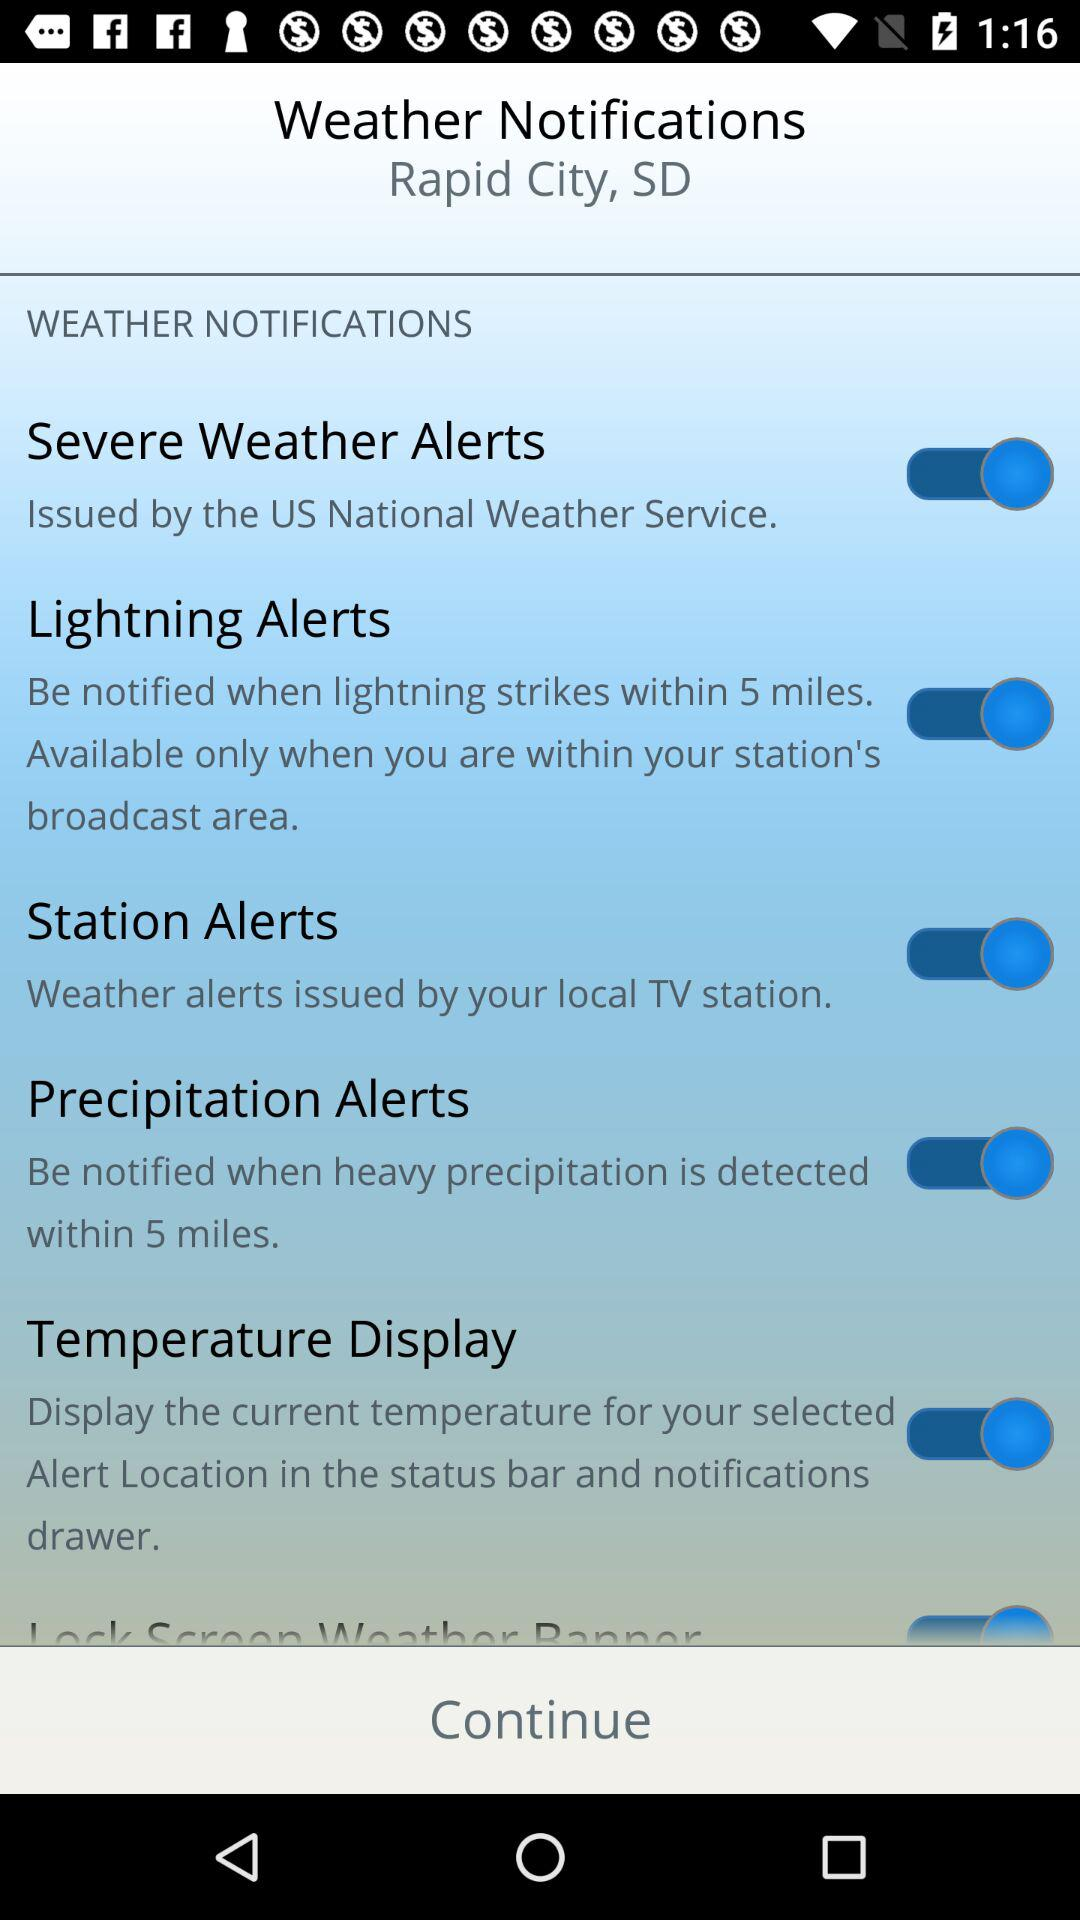Within what range will the lightning alerts be given? The lightning alerts will be given within 5 miles. 